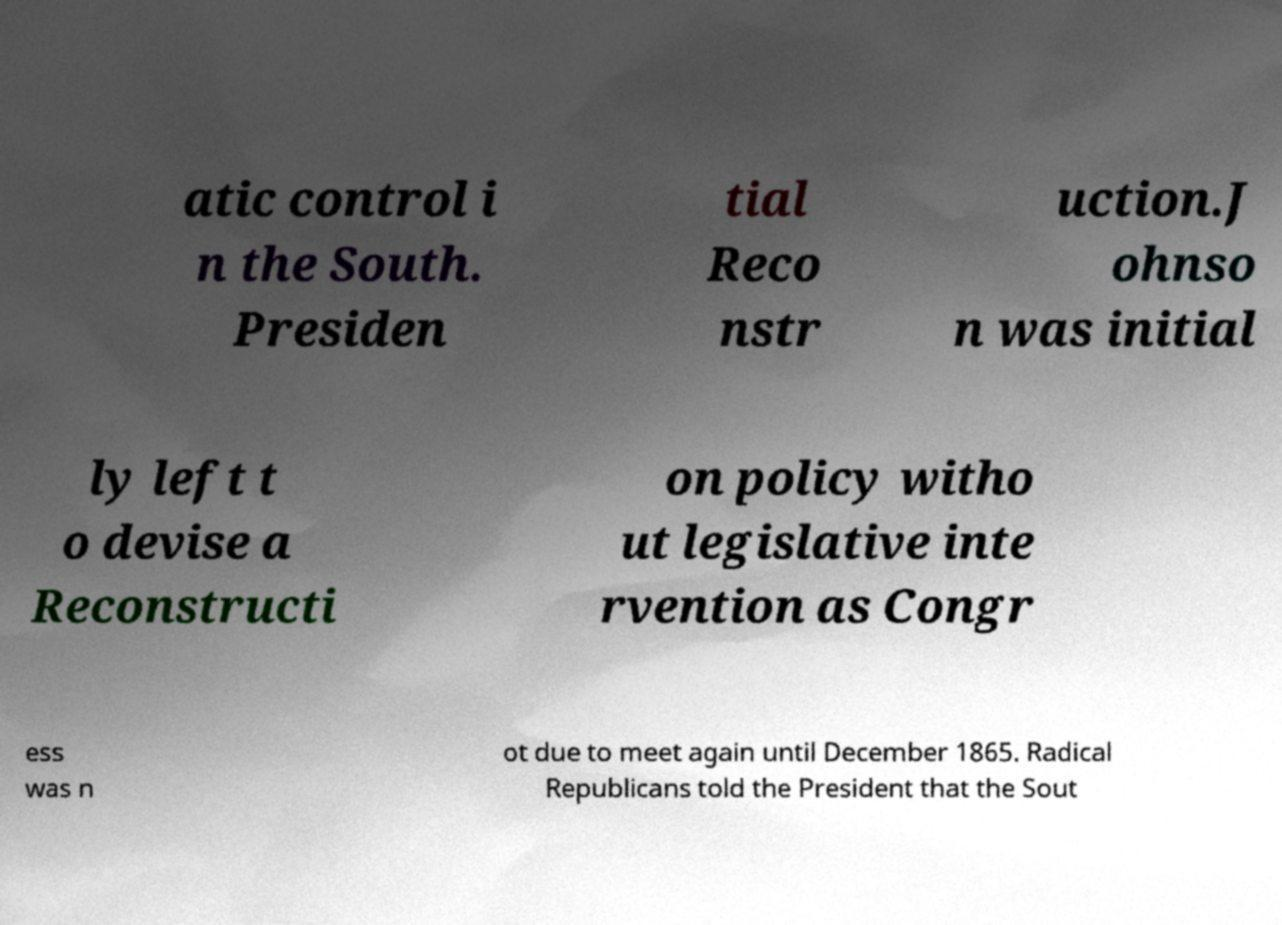There's text embedded in this image that I need extracted. Can you transcribe it verbatim? atic control i n the South. Presiden tial Reco nstr uction.J ohnso n was initial ly left t o devise a Reconstructi on policy witho ut legislative inte rvention as Congr ess was n ot due to meet again until December 1865. Radical Republicans told the President that the Sout 